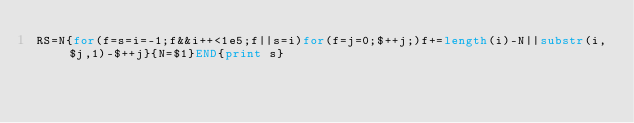<code> <loc_0><loc_0><loc_500><loc_500><_Awk_>RS=N{for(f=s=i=-1;f&&i++<1e5;f||s=i)for(f=j=0;$++j;)f+=length(i)-N||substr(i,$j,1)-$++j}{N=$1}END{print s}</code> 